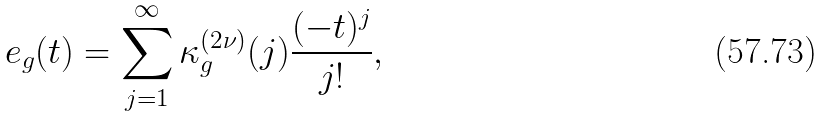<formula> <loc_0><loc_0><loc_500><loc_500>e _ { g } ( t ) = \sum _ { j = 1 } ^ { \infty } \kappa _ { g } ^ { ( 2 \nu ) } ( j ) \frac { ( - t ) ^ { j } } { j ! } ,</formula> 